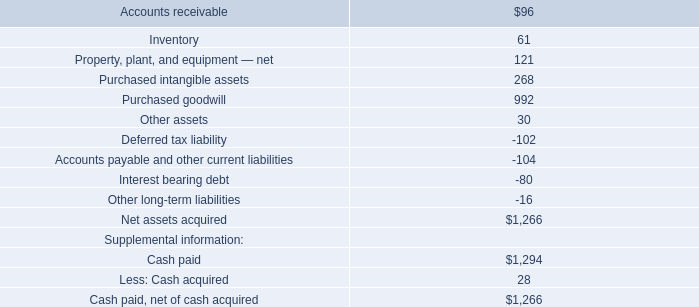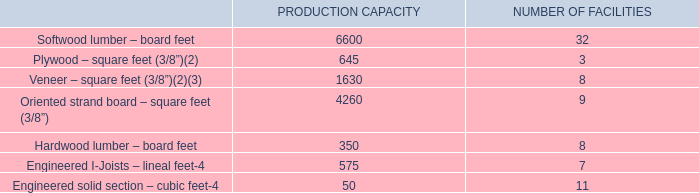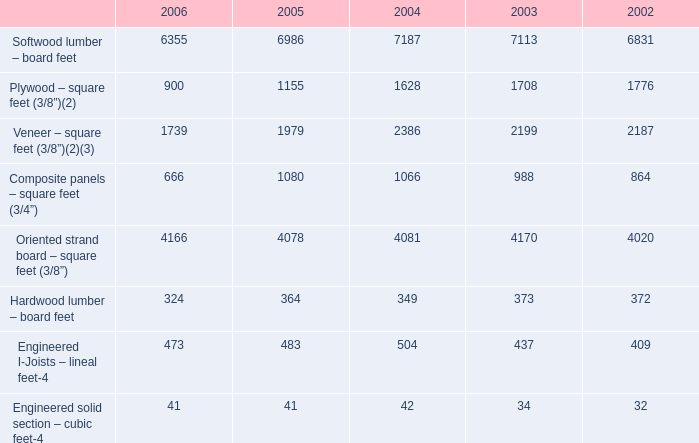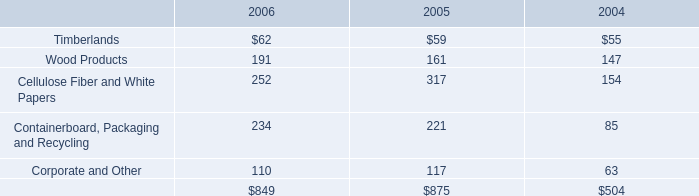What was the average of theVeneer – square feet (3/8”) in the years where Softwood lumber – board feet is positive? 
Computations: (((((1739 + 1979) + 2386) + 2199) + 2187) / 5)
Answer: 2098.0. 